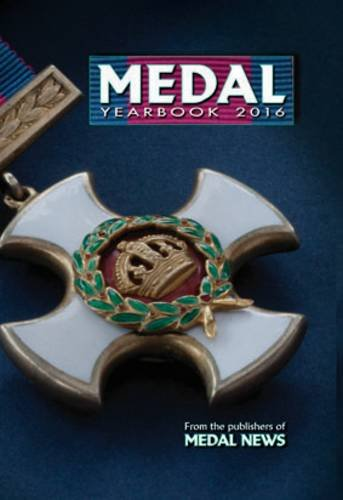Is this a historical book? While the content includes historical elements, particularly concerning the histories of various medals, it is more accurately described as a numismatic guide rather than a traditional history book. 